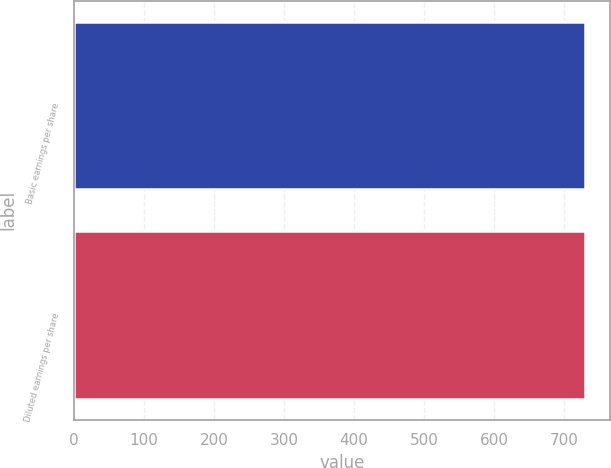Convert chart to OTSL. <chart><loc_0><loc_0><loc_500><loc_500><bar_chart><fcel>Basic earnings per share<fcel>Diluted earnings per share<nl><fcel>729.7<fcel>729.8<nl></chart> 